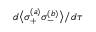Convert formula to latex. <formula><loc_0><loc_0><loc_500><loc_500>d \left \langle \sigma _ { + } ^ { ( a ) } \sigma _ { - } ^ { ( b ) } \right \rangle / d \tau</formula> 